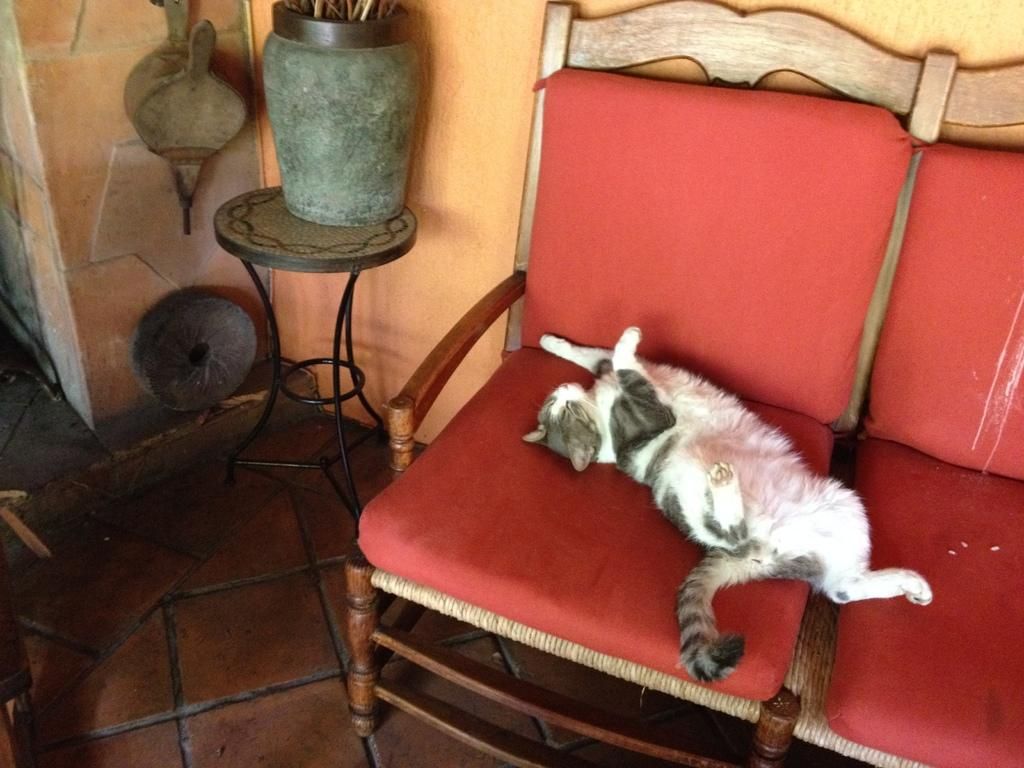What animal is present in the image? There is a cat in the image. Where is the cat located? The cat is on a chair in the image. Can you describe the cat's color pattern? The cat has a white, black, and grey color pattern. What else can be seen on the table in the image? There is a pot on a table in the image. What is visible in the background of the image? There is a wall visible in the image. What type of unit is the cat measuring in the image? There is no indication in the image that the cat is measuring anything or using any unit. 